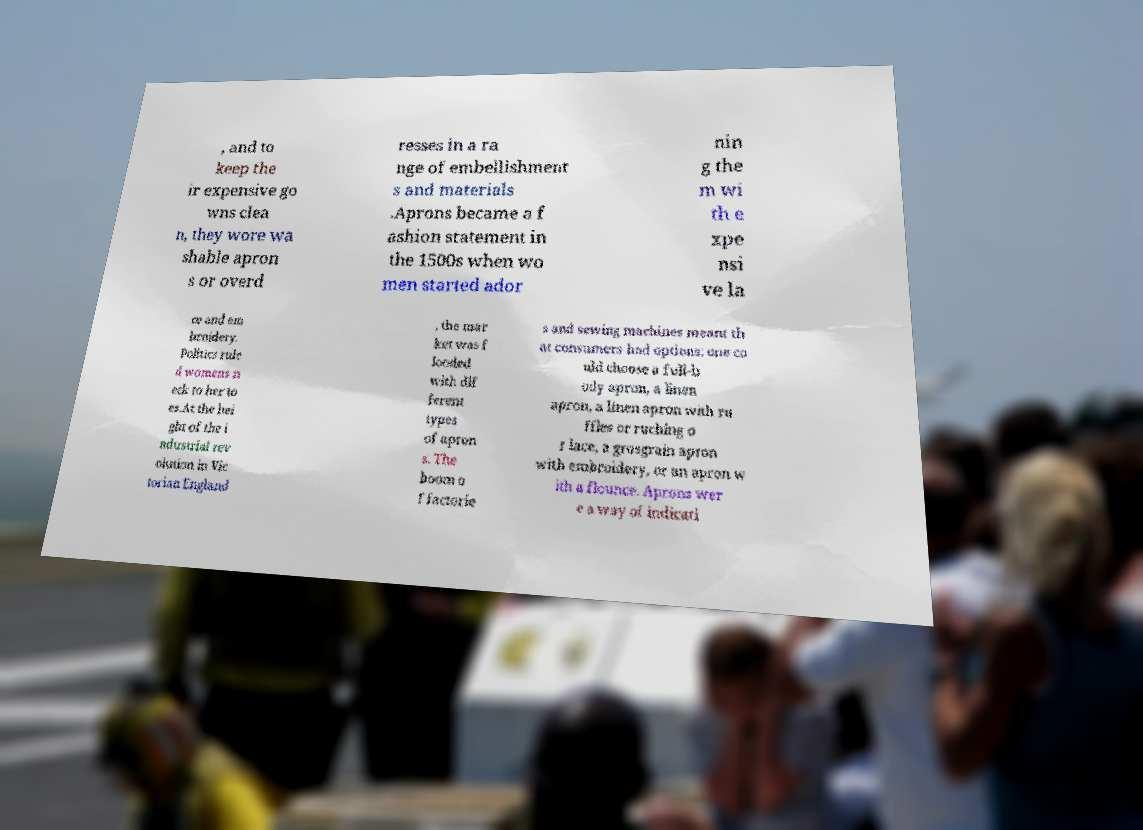For documentation purposes, I need the text within this image transcribed. Could you provide that? , and to keep the ir expensive go wns clea n, they wore wa shable apron s or overd resses in a ra nge of embellishment s and materials .Aprons became a f ashion statement in the 1500s when wo men started ador nin g the m wi th e xpe nsi ve la ce and em broidery. Politics rule d womens n eck to her to es.At the hei ght of the i ndustrial rev olution in Vic torian England , the mar ket was f looded with dif ferent types of apron s. The boom o f factorie s and sewing machines meant th at consumers had options: one co uld choose a full-b ody apron, a linen apron, a linen apron with ru ffles or ruching o r lace, a grosgrain apron with embroidery, or an apron w ith a flounce. Aprons wer e a way of indicati 